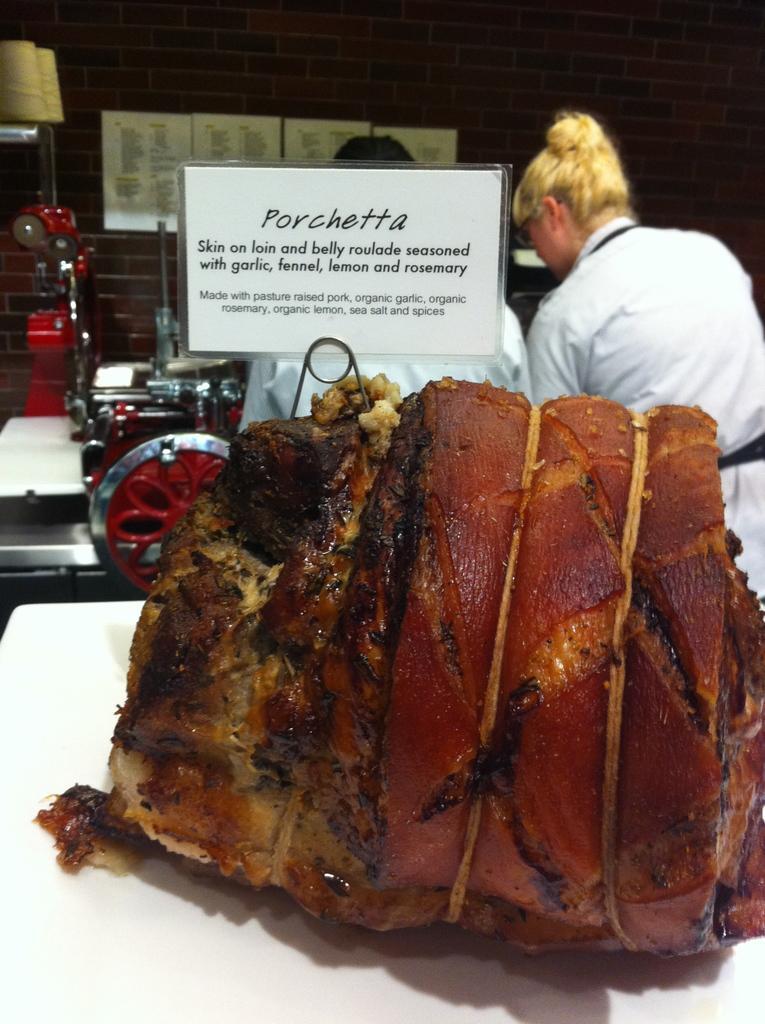In one or two sentences, can you explain what this image depicts? In this picture I can see the fried meat which is kept in a white plate. On the right there is a woman who is wearing white dress, besides her there is a man who is standing near to the table. On the table I can see the kitchen appliance. In the top left corner there is are lamps which are hanging from the roof. 